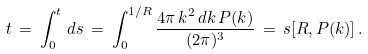<formula> <loc_0><loc_0><loc_500><loc_500>t \, = \, \int _ { 0 } ^ { t } \, d s \, = \, \int _ { 0 } ^ { 1 / R } \frac { 4 \pi \, k ^ { 2 } \, d k \, P ( k ) } { ( 2 \pi ) ^ { 3 } } \, = \, s [ R , P ( k ) ] \, .</formula> 